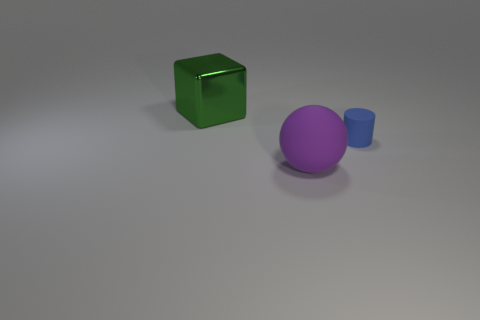Add 2 large green matte spheres. How many objects exist? 5 Subtract all cylinders. How many objects are left? 2 Subtract all purple rubber things. Subtract all purple balls. How many objects are left? 1 Add 1 rubber things. How many rubber things are left? 3 Add 2 tiny purple blocks. How many tiny purple blocks exist? 2 Subtract 0 gray spheres. How many objects are left? 3 